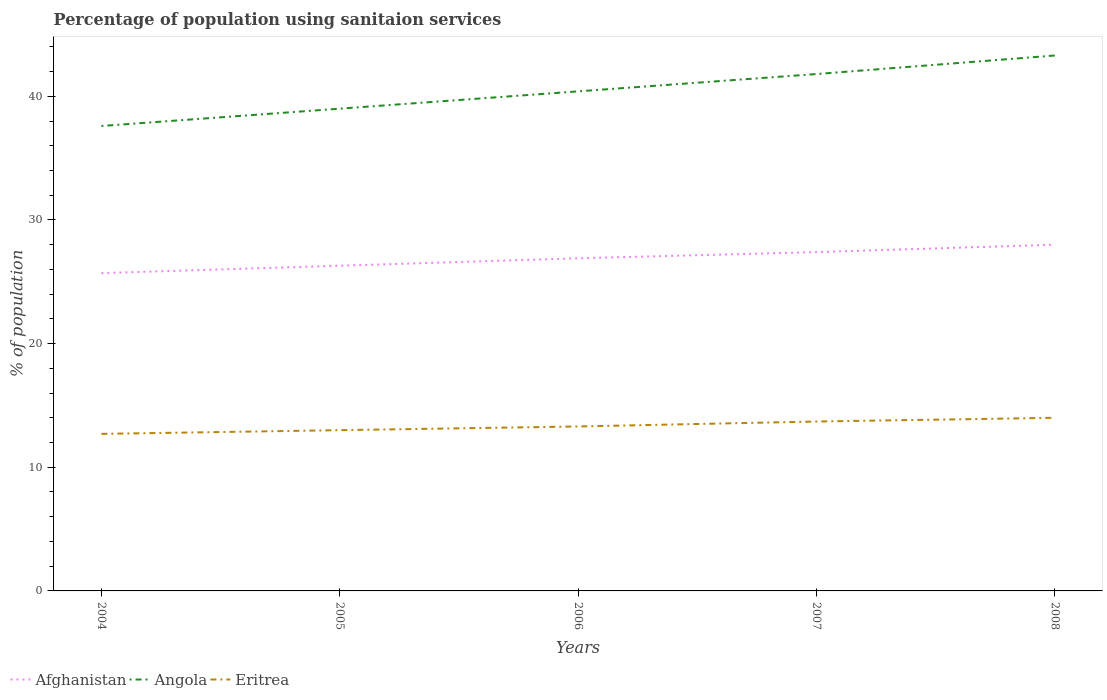Does the line corresponding to Afghanistan intersect with the line corresponding to Angola?
Your answer should be compact. No. Is the number of lines equal to the number of legend labels?
Provide a short and direct response. Yes. Across all years, what is the maximum percentage of population using sanitaion services in Angola?
Ensure brevity in your answer.  37.6. What is the total percentage of population using sanitaion services in Eritrea in the graph?
Ensure brevity in your answer.  -0.4. What is the difference between the highest and the second highest percentage of population using sanitaion services in Afghanistan?
Provide a succinct answer. 2.3. What is the difference between the highest and the lowest percentage of population using sanitaion services in Angola?
Make the answer very short. 2. How many lines are there?
Provide a succinct answer. 3. How many years are there in the graph?
Offer a terse response. 5. What is the difference between two consecutive major ticks on the Y-axis?
Offer a terse response. 10. Are the values on the major ticks of Y-axis written in scientific E-notation?
Provide a succinct answer. No. Does the graph contain any zero values?
Give a very brief answer. No. Does the graph contain grids?
Your response must be concise. No. Where does the legend appear in the graph?
Keep it short and to the point. Bottom left. How many legend labels are there?
Offer a very short reply. 3. What is the title of the graph?
Provide a succinct answer. Percentage of population using sanitaion services. Does "Samoa" appear as one of the legend labels in the graph?
Provide a succinct answer. No. What is the label or title of the Y-axis?
Your answer should be very brief. % of population. What is the % of population in Afghanistan in 2004?
Offer a terse response. 25.7. What is the % of population in Angola in 2004?
Offer a very short reply. 37.6. What is the % of population of Eritrea in 2004?
Your answer should be compact. 12.7. What is the % of population of Afghanistan in 2005?
Ensure brevity in your answer.  26.3. What is the % of population in Eritrea in 2005?
Provide a short and direct response. 13. What is the % of population in Afghanistan in 2006?
Keep it short and to the point. 26.9. What is the % of population of Angola in 2006?
Give a very brief answer. 40.4. What is the % of population in Eritrea in 2006?
Your response must be concise. 13.3. What is the % of population of Afghanistan in 2007?
Make the answer very short. 27.4. What is the % of population in Angola in 2007?
Give a very brief answer. 41.8. What is the % of population in Afghanistan in 2008?
Make the answer very short. 28. What is the % of population of Angola in 2008?
Provide a short and direct response. 43.3. What is the % of population in Eritrea in 2008?
Provide a succinct answer. 14. Across all years, what is the maximum % of population of Afghanistan?
Provide a succinct answer. 28. Across all years, what is the maximum % of population of Angola?
Offer a terse response. 43.3. Across all years, what is the maximum % of population in Eritrea?
Your response must be concise. 14. Across all years, what is the minimum % of population in Afghanistan?
Your response must be concise. 25.7. Across all years, what is the minimum % of population in Angola?
Offer a very short reply. 37.6. Across all years, what is the minimum % of population of Eritrea?
Your response must be concise. 12.7. What is the total % of population of Afghanistan in the graph?
Make the answer very short. 134.3. What is the total % of population of Angola in the graph?
Offer a terse response. 202.1. What is the total % of population in Eritrea in the graph?
Make the answer very short. 66.7. What is the difference between the % of population of Afghanistan in 2004 and that in 2005?
Ensure brevity in your answer.  -0.6. What is the difference between the % of population of Angola in 2004 and that in 2005?
Make the answer very short. -1.4. What is the difference between the % of population of Eritrea in 2004 and that in 2005?
Your answer should be compact. -0.3. What is the difference between the % of population in Afghanistan in 2004 and that in 2006?
Your answer should be compact. -1.2. What is the difference between the % of population in Angola in 2004 and that in 2006?
Make the answer very short. -2.8. What is the difference between the % of population in Eritrea in 2004 and that in 2007?
Ensure brevity in your answer.  -1. What is the difference between the % of population of Eritrea in 2005 and that in 2006?
Provide a short and direct response. -0.3. What is the difference between the % of population of Afghanistan in 2005 and that in 2007?
Provide a short and direct response. -1.1. What is the difference between the % of population of Afghanistan in 2005 and that in 2008?
Provide a short and direct response. -1.7. What is the difference between the % of population in Angola in 2005 and that in 2008?
Provide a short and direct response. -4.3. What is the difference between the % of population in Angola in 2006 and that in 2008?
Your answer should be very brief. -2.9. What is the difference between the % of population of Afghanistan in 2004 and the % of population of Angola in 2005?
Offer a very short reply. -13.3. What is the difference between the % of population of Angola in 2004 and the % of population of Eritrea in 2005?
Provide a short and direct response. 24.6. What is the difference between the % of population in Afghanistan in 2004 and the % of population in Angola in 2006?
Give a very brief answer. -14.7. What is the difference between the % of population of Afghanistan in 2004 and the % of population of Eritrea in 2006?
Make the answer very short. 12.4. What is the difference between the % of population of Angola in 2004 and the % of population of Eritrea in 2006?
Your response must be concise. 24.3. What is the difference between the % of population in Afghanistan in 2004 and the % of population in Angola in 2007?
Offer a terse response. -16.1. What is the difference between the % of population of Afghanistan in 2004 and the % of population of Eritrea in 2007?
Give a very brief answer. 12. What is the difference between the % of population of Angola in 2004 and the % of population of Eritrea in 2007?
Give a very brief answer. 23.9. What is the difference between the % of population of Afghanistan in 2004 and the % of population of Angola in 2008?
Your answer should be compact. -17.6. What is the difference between the % of population of Angola in 2004 and the % of population of Eritrea in 2008?
Keep it short and to the point. 23.6. What is the difference between the % of population of Afghanistan in 2005 and the % of population of Angola in 2006?
Your answer should be very brief. -14.1. What is the difference between the % of population in Afghanistan in 2005 and the % of population in Eritrea in 2006?
Offer a very short reply. 13. What is the difference between the % of population of Angola in 2005 and the % of population of Eritrea in 2006?
Your answer should be compact. 25.7. What is the difference between the % of population in Afghanistan in 2005 and the % of population in Angola in 2007?
Your response must be concise. -15.5. What is the difference between the % of population in Afghanistan in 2005 and the % of population in Eritrea in 2007?
Give a very brief answer. 12.6. What is the difference between the % of population of Angola in 2005 and the % of population of Eritrea in 2007?
Your answer should be compact. 25.3. What is the difference between the % of population in Afghanistan in 2005 and the % of population in Angola in 2008?
Your answer should be very brief. -17. What is the difference between the % of population in Afghanistan in 2006 and the % of population in Angola in 2007?
Your answer should be very brief. -14.9. What is the difference between the % of population of Afghanistan in 2006 and the % of population of Eritrea in 2007?
Offer a terse response. 13.2. What is the difference between the % of population in Angola in 2006 and the % of population in Eritrea in 2007?
Provide a succinct answer. 26.7. What is the difference between the % of population in Afghanistan in 2006 and the % of population in Angola in 2008?
Offer a very short reply. -16.4. What is the difference between the % of population of Afghanistan in 2006 and the % of population of Eritrea in 2008?
Give a very brief answer. 12.9. What is the difference between the % of population of Angola in 2006 and the % of population of Eritrea in 2008?
Your answer should be very brief. 26.4. What is the difference between the % of population of Afghanistan in 2007 and the % of population of Angola in 2008?
Your answer should be very brief. -15.9. What is the difference between the % of population of Angola in 2007 and the % of population of Eritrea in 2008?
Your response must be concise. 27.8. What is the average % of population in Afghanistan per year?
Provide a short and direct response. 26.86. What is the average % of population of Angola per year?
Make the answer very short. 40.42. What is the average % of population of Eritrea per year?
Provide a short and direct response. 13.34. In the year 2004, what is the difference between the % of population in Afghanistan and % of population in Eritrea?
Ensure brevity in your answer.  13. In the year 2004, what is the difference between the % of population in Angola and % of population in Eritrea?
Your answer should be very brief. 24.9. In the year 2005, what is the difference between the % of population of Afghanistan and % of population of Angola?
Ensure brevity in your answer.  -12.7. In the year 2005, what is the difference between the % of population of Afghanistan and % of population of Eritrea?
Offer a very short reply. 13.3. In the year 2005, what is the difference between the % of population of Angola and % of population of Eritrea?
Provide a short and direct response. 26. In the year 2006, what is the difference between the % of population of Afghanistan and % of population of Eritrea?
Keep it short and to the point. 13.6. In the year 2006, what is the difference between the % of population in Angola and % of population in Eritrea?
Provide a short and direct response. 27.1. In the year 2007, what is the difference between the % of population of Afghanistan and % of population of Angola?
Offer a terse response. -14.4. In the year 2007, what is the difference between the % of population in Afghanistan and % of population in Eritrea?
Your answer should be very brief. 13.7. In the year 2007, what is the difference between the % of population in Angola and % of population in Eritrea?
Offer a terse response. 28.1. In the year 2008, what is the difference between the % of population in Afghanistan and % of population in Angola?
Your answer should be compact. -15.3. In the year 2008, what is the difference between the % of population of Afghanistan and % of population of Eritrea?
Offer a terse response. 14. In the year 2008, what is the difference between the % of population in Angola and % of population in Eritrea?
Keep it short and to the point. 29.3. What is the ratio of the % of population of Afghanistan in 2004 to that in 2005?
Offer a very short reply. 0.98. What is the ratio of the % of population of Angola in 2004 to that in 2005?
Ensure brevity in your answer.  0.96. What is the ratio of the % of population of Eritrea in 2004 to that in 2005?
Your answer should be very brief. 0.98. What is the ratio of the % of population in Afghanistan in 2004 to that in 2006?
Keep it short and to the point. 0.96. What is the ratio of the % of population in Angola in 2004 to that in 2006?
Provide a short and direct response. 0.93. What is the ratio of the % of population in Eritrea in 2004 to that in 2006?
Your answer should be very brief. 0.95. What is the ratio of the % of population of Afghanistan in 2004 to that in 2007?
Keep it short and to the point. 0.94. What is the ratio of the % of population in Angola in 2004 to that in 2007?
Your answer should be compact. 0.9. What is the ratio of the % of population of Eritrea in 2004 to that in 2007?
Your answer should be very brief. 0.93. What is the ratio of the % of population of Afghanistan in 2004 to that in 2008?
Your answer should be very brief. 0.92. What is the ratio of the % of population in Angola in 2004 to that in 2008?
Give a very brief answer. 0.87. What is the ratio of the % of population of Eritrea in 2004 to that in 2008?
Ensure brevity in your answer.  0.91. What is the ratio of the % of population in Afghanistan in 2005 to that in 2006?
Make the answer very short. 0.98. What is the ratio of the % of population in Angola in 2005 to that in 2006?
Offer a terse response. 0.97. What is the ratio of the % of population in Eritrea in 2005 to that in 2006?
Give a very brief answer. 0.98. What is the ratio of the % of population in Afghanistan in 2005 to that in 2007?
Your answer should be compact. 0.96. What is the ratio of the % of population in Angola in 2005 to that in 2007?
Your response must be concise. 0.93. What is the ratio of the % of population of Eritrea in 2005 to that in 2007?
Your answer should be very brief. 0.95. What is the ratio of the % of population of Afghanistan in 2005 to that in 2008?
Your answer should be compact. 0.94. What is the ratio of the % of population in Angola in 2005 to that in 2008?
Offer a very short reply. 0.9. What is the ratio of the % of population of Eritrea in 2005 to that in 2008?
Provide a short and direct response. 0.93. What is the ratio of the % of population in Afghanistan in 2006 to that in 2007?
Provide a short and direct response. 0.98. What is the ratio of the % of population of Angola in 2006 to that in 2007?
Your answer should be compact. 0.97. What is the ratio of the % of population of Eritrea in 2006 to that in 2007?
Provide a short and direct response. 0.97. What is the ratio of the % of population of Afghanistan in 2006 to that in 2008?
Your response must be concise. 0.96. What is the ratio of the % of population in Angola in 2006 to that in 2008?
Your answer should be compact. 0.93. What is the ratio of the % of population of Eritrea in 2006 to that in 2008?
Your answer should be very brief. 0.95. What is the ratio of the % of population of Afghanistan in 2007 to that in 2008?
Offer a terse response. 0.98. What is the ratio of the % of population of Angola in 2007 to that in 2008?
Keep it short and to the point. 0.97. What is the ratio of the % of population in Eritrea in 2007 to that in 2008?
Offer a very short reply. 0.98. What is the difference between the highest and the second highest % of population in Afghanistan?
Offer a terse response. 0.6. What is the difference between the highest and the second highest % of population of Angola?
Make the answer very short. 1.5. What is the difference between the highest and the second highest % of population of Eritrea?
Offer a terse response. 0.3. What is the difference between the highest and the lowest % of population of Afghanistan?
Your answer should be very brief. 2.3. What is the difference between the highest and the lowest % of population in Angola?
Make the answer very short. 5.7. What is the difference between the highest and the lowest % of population in Eritrea?
Offer a very short reply. 1.3. 